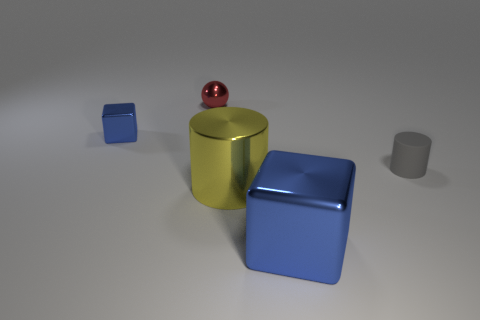Is there anything else that is the same material as the tiny gray cylinder?
Your response must be concise. No. Is the number of blue shiny objects to the right of the shiny sphere less than the number of cylinders?
Offer a very short reply. Yes. Does the gray object have the same shape as the red shiny thing?
Offer a very short reply. No. Is there any other thing that is the same shape as the red metallic object?
Your answer should be compact. No. Are any tiny green metal cylinders visible?
Your answer should be very brief. No. Is the shape of the tiny red object the same as the metal object right of the large yellow metal cylinder?
Your answer should be compact. No. There is a blue cube in front of the small shiny thing in front of the red metal sphere; what is it made of?
Make the answer very short. Metal. What color is the small shiny block?
Offer a terse response. Blue. There is a small shiny object that is right of the small block; is it the same color as the block on the right side of the big yellow shiny cylinder?
Offer a terse response. No. There is another blue object that is the same shape as the small blue metallic object; what size is it?
Offer a terse response. Large. 